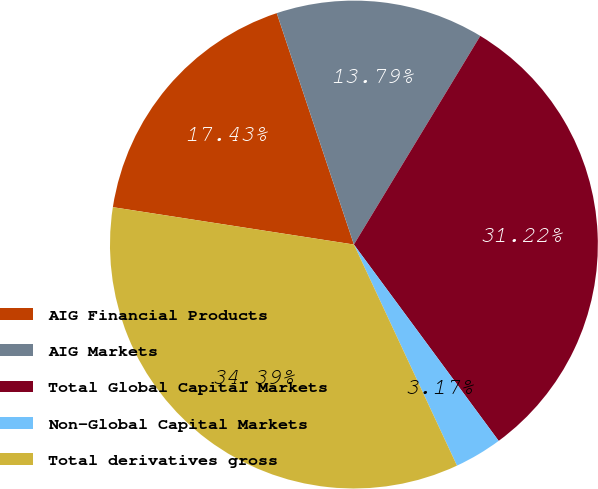<chart> <loc_0><loc_0><loc_500><loc_500><pie_chart><fcel>AIG Financial Products<fcel>AIG Markets<fcel>Total Global Capital Markets<fcel>Non-Global Capital Markets<fcel>Total derivatives gross<nl><fcel>17.43%<fcel>13.79%<fcel>31.22%<fcel>3.17%<fcel>34.39%<nl></chart> 